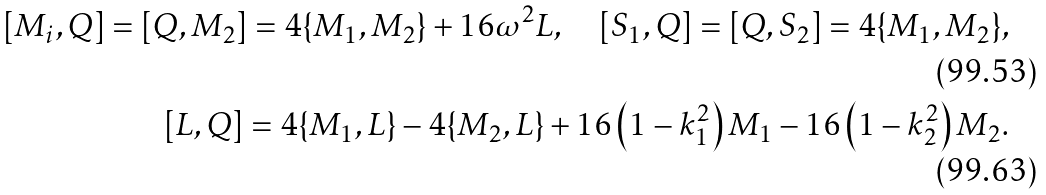Convert formula to latex. <formula><loc_0><loc_0><loc_500><loc_500>[ M _ { i } , Q ] = [ Q , M _ { 2 } ] = 4 \{ M _ { 1 } , M _ { 2 } \} + 1 6 \omega ^ { 2 } L , \quad [ S _ { 1 } , Q ] = [ Q , S _ { 2 } ] = 4 \{ M _ { 1 } , M _ { 2 } \} , \\ [ L , Q ] = 4 \{ M _ { 1 } , L \} - 4 \{ M _ { 2 } , L \} + 1 6 \left ( 1 - k ^ { 2 } _ { 1 } \right ) M _ { 1 } - 1 6 \left ( 1 - k ^ { 2 } _ { 2 } \right ) M _ { 2 } .</formula> 